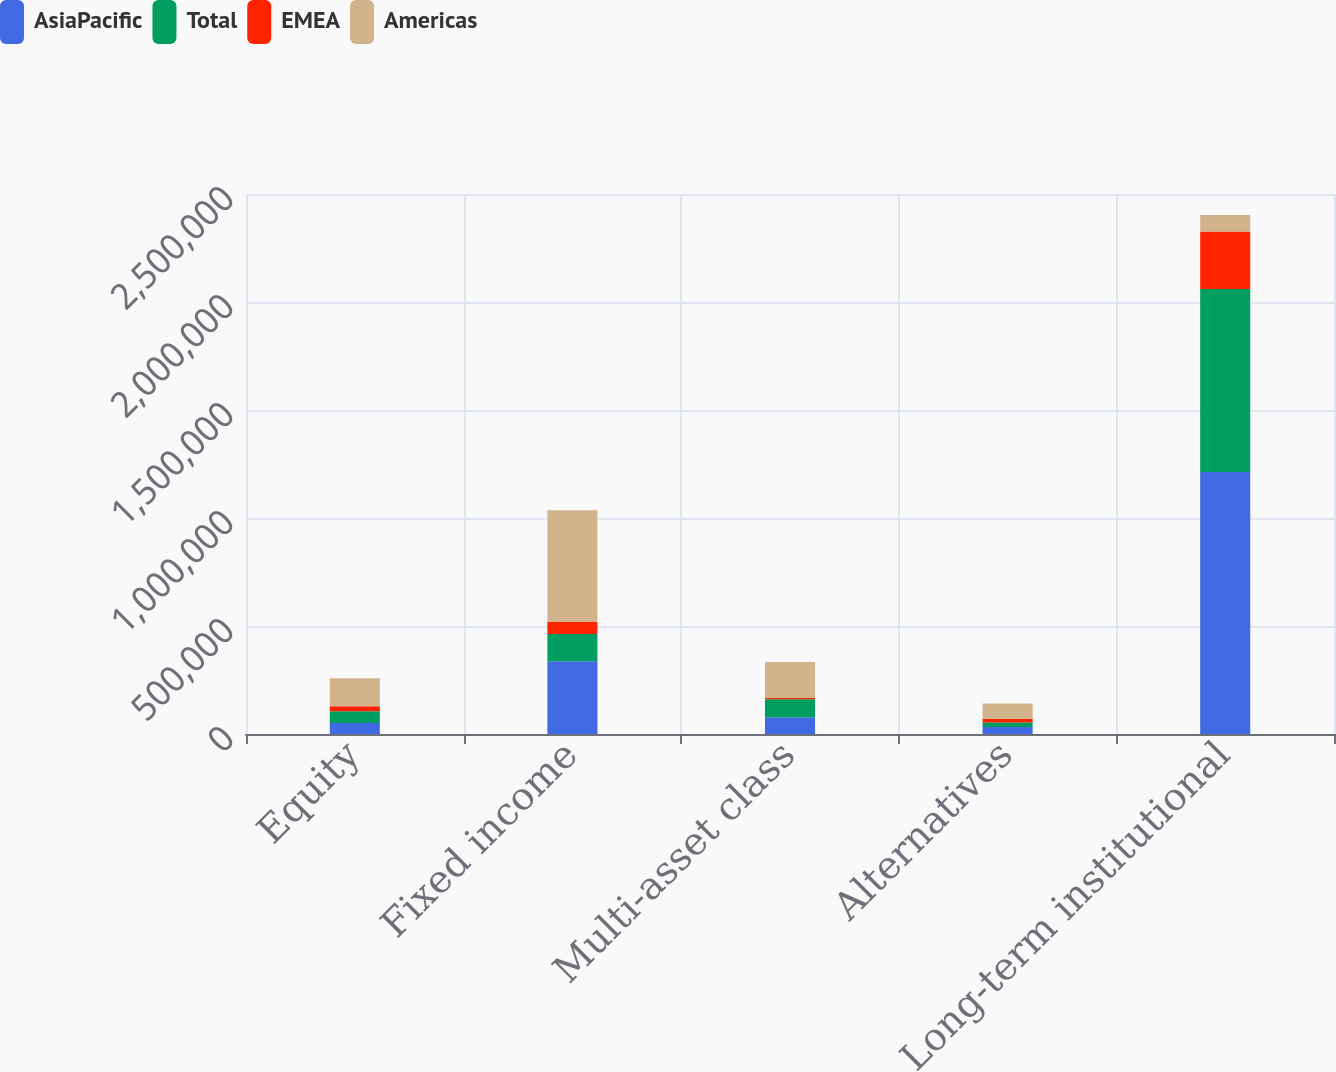Convert chart. <chart><loc_0><loc_0><loc_500><loc_500><stacked_bar_chart><ecel><fcel>Equity<fcel>Fixed income<fcel>Multi-asset class<fcel>Alternatives<fcel>Long-term institutional<nl><fcel>AsiaPacific<fcel>51242<fcel>336998<fcel>77105<fcel>32362<fcel>1.21288e+06<nl><fcel>Total<fcel>54499<fcel>126530<fcel>83797<fcel>20507<fcel>847829<nl><fcel>EMEA<fcel>23283<fcel>54575<fcel>5805<fcel>17992<fcel>265470<nl><fcel>Americas<fcel>129024<fcel>518103<fcel>166707<fcel>70861<fcel>77105<nl></chart> 